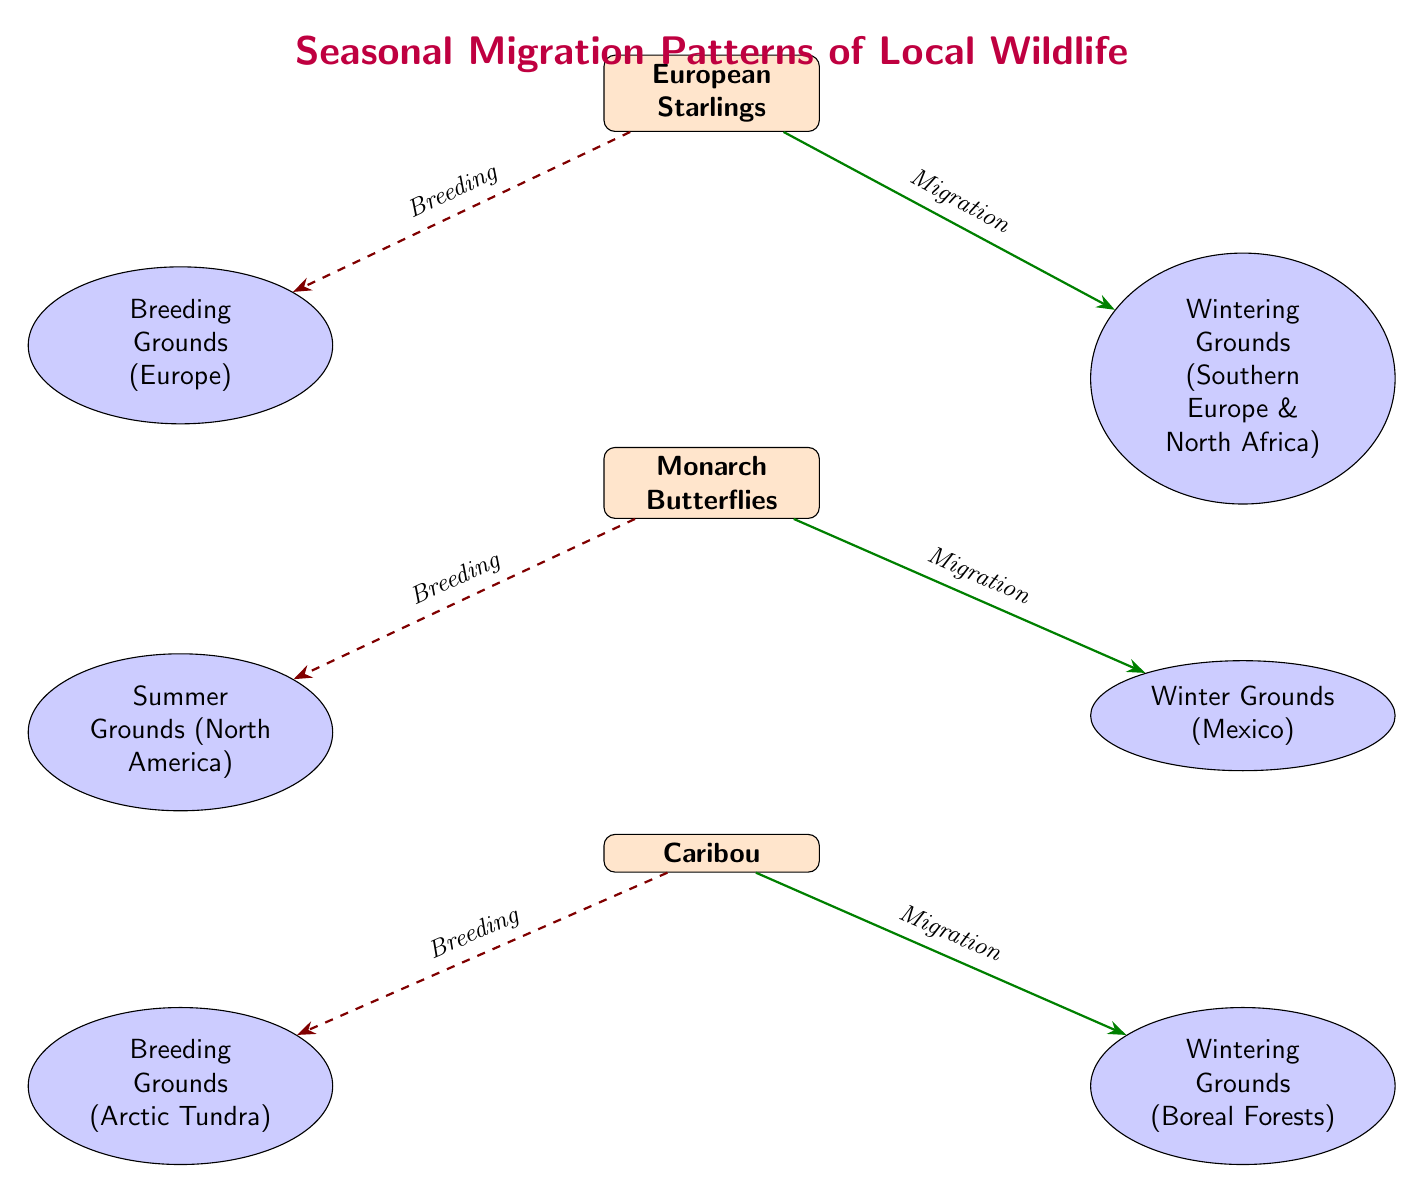What species are depicted in the diagram? The diagram shows three species: European Starlings, Monarch Butterflies, and Caribou. Each species is labeled at the top of each section in the diagram.
Answer: European Starlings, Monarch Butterflies, Caribou How many breeding grounds are shown in the diagram? There are three breeding grounds in the diagram, one for each species: Europe for the Starlings, North America for the Butterflies, and the Arctic Tundra for the Caribou. Each species has one corresponding breeding location.
Answer: 3 What is the wintering ground for the Monarch Butterflies? The wintering ground for the Monarch Butterflies is Mexico, which is indicated by the location connected to the butterfly species with a migration arrow.
Answer: Mexico What type of relationship exists between the Caribou and Arctic Tundra? The relationship between the Caribou and Arctic Tundra is labeled "Breeding," shown by a dashed red line indicating a breeding ground linked to the species node.
Answer: Breeding Which two locations are connected by migration arrows? The migration arrows connect the species to their wintering grounds; for example, the European Starlings migrate to Southern Europe & North Africa and the Monarch Butterflies migrate to Mexico. This is indicated by the green migration arrows leading to wintering grounds.
Answer: Southern Europe & North Africa, Mexico Explain the migration pattern of European Starlings. European Starlings breed in Europe, then migrate to their wintering grounds located in Southern Europe and North Africa. This pattern is illustrated with a breeding arrow leading to the breeding grounds and a migration arrow pointing to the wintering grounds.
Answer: Europe to Southern Europe & North Africa How are the breeding and migration patterns different for the Caribou compared to the European Starlings? The Caribou breed in the Arctic Tundra and migrate to Boreal Forests, while the European Starlings breed in Europe and migrate to Southern Europe & North Africa. The differences lie in the specific locations associated with each species for breeding and wintering, and they originate from different climate regions.
Answer: Different locations What do the dashed lines represent in the diagram? The dashed lines represent the breeding relationships between each species and their respective breeding grounds, indicating where they reproduce. This style is distinct from solid migration lines, which show where species travel for wintering.
Answer: Breeding relationships 